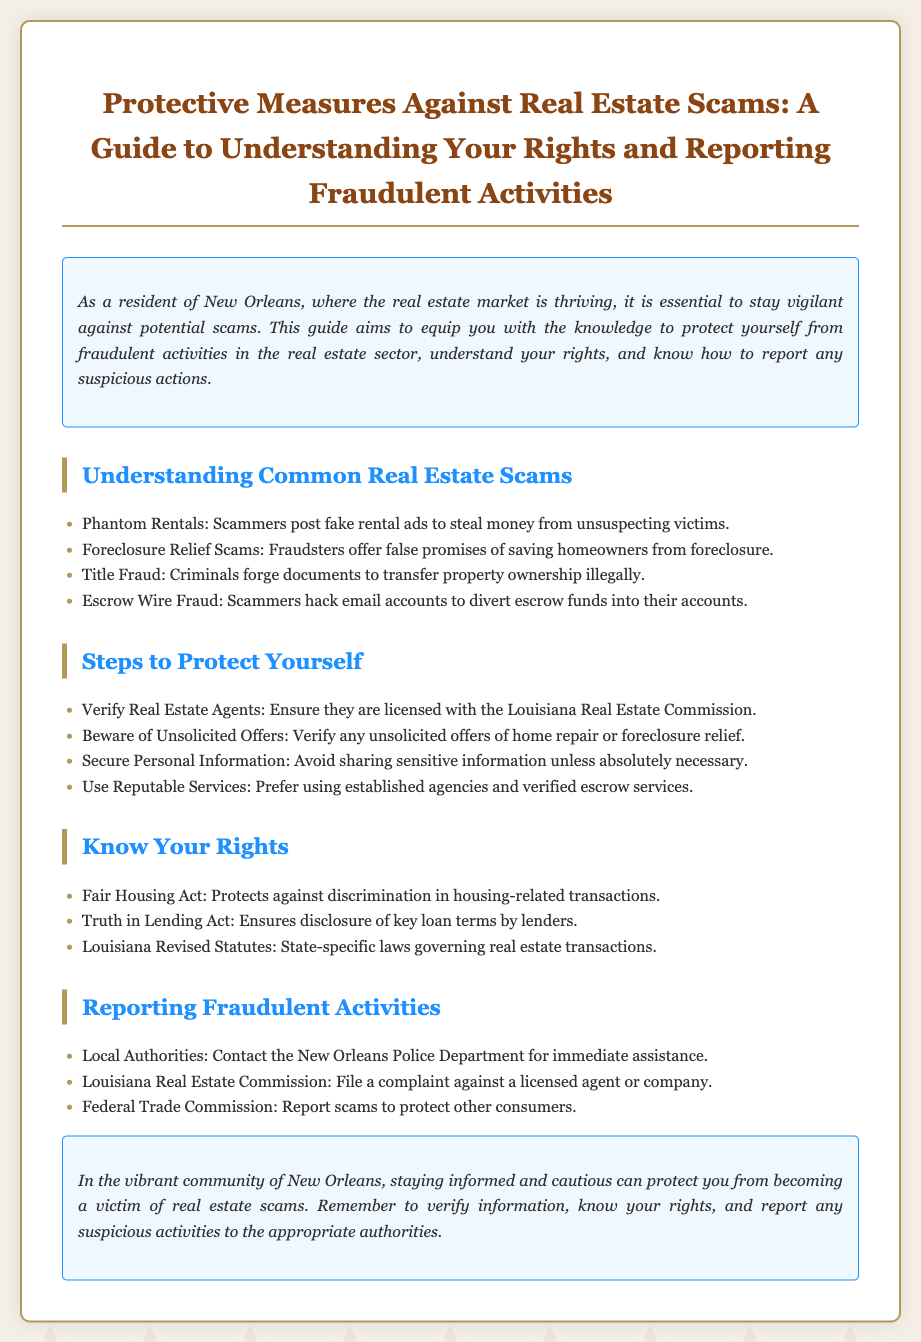What are phantom rentals? Phantom rentals are scams where scammers post fake rental ads to steal money from unsuspecting victims.
Answer: Fake rental ads What should you verify about real estate agents? You should verify that they are licensed with the Louisiana Real Estate Commission.
Answer: Licensed What does the Fair Housing Act protect against? The Fair Housing Act protects against discrimination in housing-related transactions.
Answer: Discrimination How many steps are listed to protect yourself? There are four steps listed to protect yourself.
Answer: Four Who should you contact for immediate assistance with fraud? You should contact the New Orleans Police Department for immediate assistance.
Answer: New Orleans Police Department What can you report to the Federal Trade Commission? You can report scams to protect other consumers.
Answer: Scams What act ensures disclosure of key loan terms by lenders? The Truth in Lending Act ensures disclosure of key loan terms by lenders.
Answer: Truth in Lending Act What should you prefer when using services in real estate? Prefer using established agencies and verified escrow services.
Answer: Established agencies What is a common type of real estate scam involving email? Escrow wire fraud is a common type of scam involving email.
Answer: Escrow wire fraud 